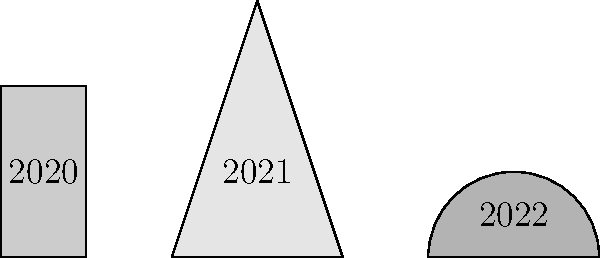Our team has won trophies in the last three years, each with a unique shape. The 2020 trophy is rectangular, the 2021 trophy is triangular, and the 2022 trophy is semicircular. If the 2020 trophy has a height of 2 units and a width of 1 unit, the 2021 trophy has a base of 2 units and a height of 3 units, and the 2022 trophy has a diameter of 2 units, which year's trophy has the largest area? Let's calculate the area of each trophy:

1. 2020 Trophy (Rectangle):
   Area = length × width
   $A_{2020} = 2 \times 1 = 2$ square units

2. 2021 Trophy (Triangle):
   Area = $\frac{1}{2} \times$ base × height
   $A_{2021} = \frac{1}{2} \times 2 \times 3 = 3$ square units

3. 2022 Trophy (Semicircle):
   Area = $\frac{1}{2} \times \pi r^2$, where $r$ is the radius (half of the diameter)
   $A_{2022} = \frac{1}{2} \times \pi \times 1^2 = \frac{\pi}{2} \approx 1.57$ square units

Comparing the areas:
$A_{2021} > A_{2020} > A_{2022}$

Therefore, the 2021 trophy has the largest area.
Answer: 2021 